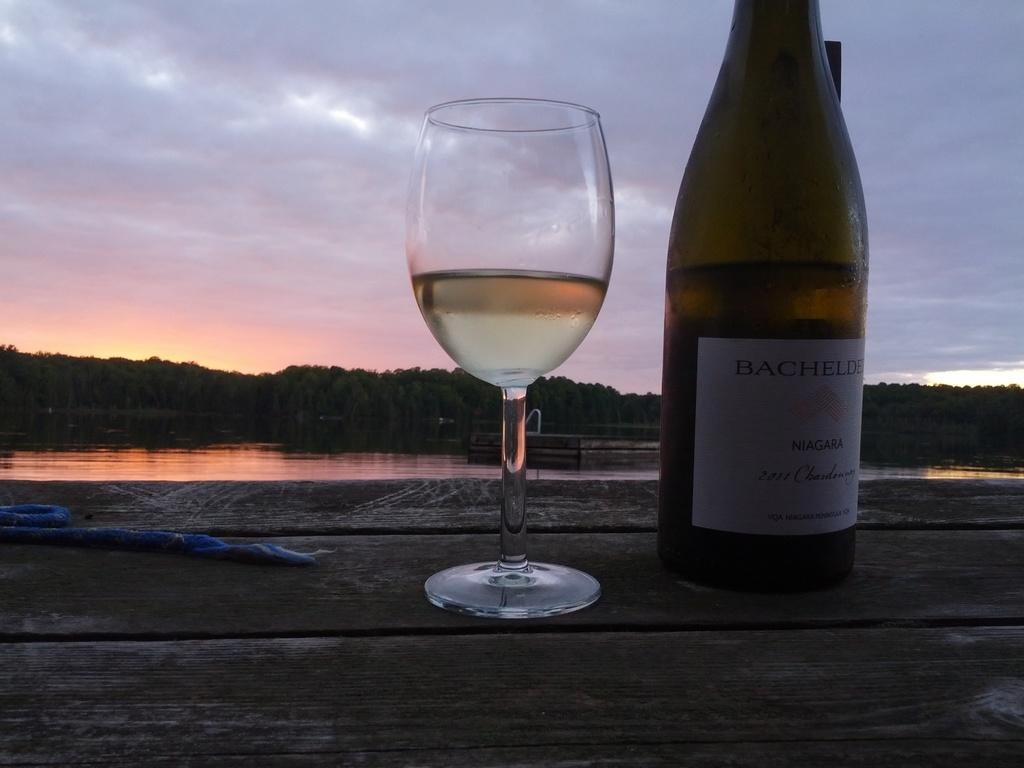What is in the glass that is visible in the image? There is a drink in the glass in the image. What is on the bottle that is visible in the image? There is a sticker on the bottle in the image. Where is the bottle placed in the image? The bottle is placed on a wooden platform in the image. What can be seen in the background of the image? Trees, water, and the sky are visible in the background of the image. What is present in the sky in the image? Clouds are present in the sky in the image. What type of lettuce is being used as a coaster for the glass in the image? There is no lettuce present in the image, and the glass is not resting on any lettuce. 